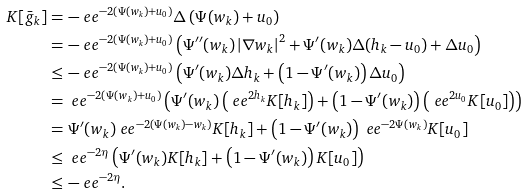<formula> <loc_0><loc_0><loc_500><loc_500>K [ \bar { g } _ { k } ] & = - \ e e ^ { - 2 \left ( \Psi ( w _ { k } ) + u _ { 0 } \right ) } \Delta \left ( \Psi ( w _ { k } ) + u _ { 0 } \right ) \\ & = - \ e e ^ { - 2 \left ( \Psi ( w _ { k } ) + u _ { 0 } \right ) } \left ( \Psi ^ { \prime \prime } ( w _ { k } ) \left | \nabla w _ { k } \right | ^ { 2 } + \Psi ^ { \prime } ( w _ { k } ) \Delta ( h _ { k } - u _ { 0 } ) + \Delta u _ { 0 } \right ) \\ & \leq - \ e e ^ { - 2 \left ( \Psi ( w _ { k } ) + u _ { 0 } \right ) } \left ( \Psi ^ { \prime } ( w _ { k } ) \Delta h _ { k } + \left ( 1 - \Psi ^ { \prime } ( w _ { k } ) \right ) \Delta u _ { 0 } \right ) \\ & = \ e e ^ { - 2 \left ( \Psi ( w _ { k } ) + u _ { 0 } \right ) } \left ( \Psi ^ { \prime } ( w _ { k } ) \left ( \ e e ^ { 2 h _ { k } } K [ h _ { k } ] \right ) + \left ( 1 - \Psi ^ { \prime } ( w _ { k } ) \right ) \left ( \ e e ^ { 2 u _ { 0 } } K [ u _ { 0 } ] \right ) \right ) \\ & = \Psi ^ { \prime } ( w _ { k } ) \ e e ^ { - 2 \left ( \Psi ( w _ { k } ) - w _ { k } \right ) } K [ h _ { k } ] + \left ( 1 - \Psi ^ { \prime } ( w _ { k } ) \right ) \ e e ^ { - 2 \Psi ( w _ { k } ) } K [ u _ { 0 } ] \\ & \leq \ e e ^ { - 2 \eta } \left ( \Psi ^ { \prime } ( w _ { k } ) K [ h _ { k } ] + \left ( 1 - \Psi ^ { \prime } ( w _ { k } ) \right ) K [ u _ { 0 } ] \right ) \\ & \leq - \ e e ^ { - 2 \eta } .</formula> 